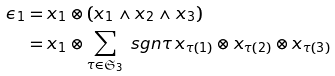<formula> <loc_0><loc_0><loc_500><loc_500>\epsilon _ { 1 } & = x _ { 1 } \otimes ( x _ { 1 } \wedge x _ { 2 } \wedge x _ { 3 } ) \\ & = x _ { 1 } \otimes \sum _ { \tau \in \mathfrak { S } _ { 3 } } \ s g n \tau \, x _ { \tau ( 1 ) } \otimes x _ { \tau ( 2 ) } \otimes x _ { \tau ( 3 ) }</formula> 